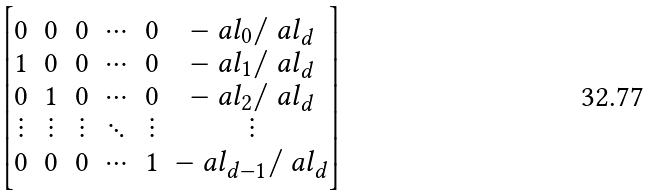Convert formula to latex. <formula><loc_0><loc_0><loc_500><loc_500>\begin{bmatrix} 0 & 0 & 0 & \cdots & 0 & - \ a l _ { 0 } / \ a l _ { d } \\ 1 & 0 & 0 & \cdots & 0 & - \ a l _ { 1 } / \ a l _ { d } \\ 0 & 1 & 0 & \cdots & 0 & - \ a l _ { 2 } / \ a l _ { d } \\ \vdots & \vdots & \vdots & \ddots & \vdots & \vdots \\ 0 & 0 & 0 & \cdots & 1 & - \ a l _ { d - 1 } / \ a l _ { d } \end{bmatrix}</formula> 